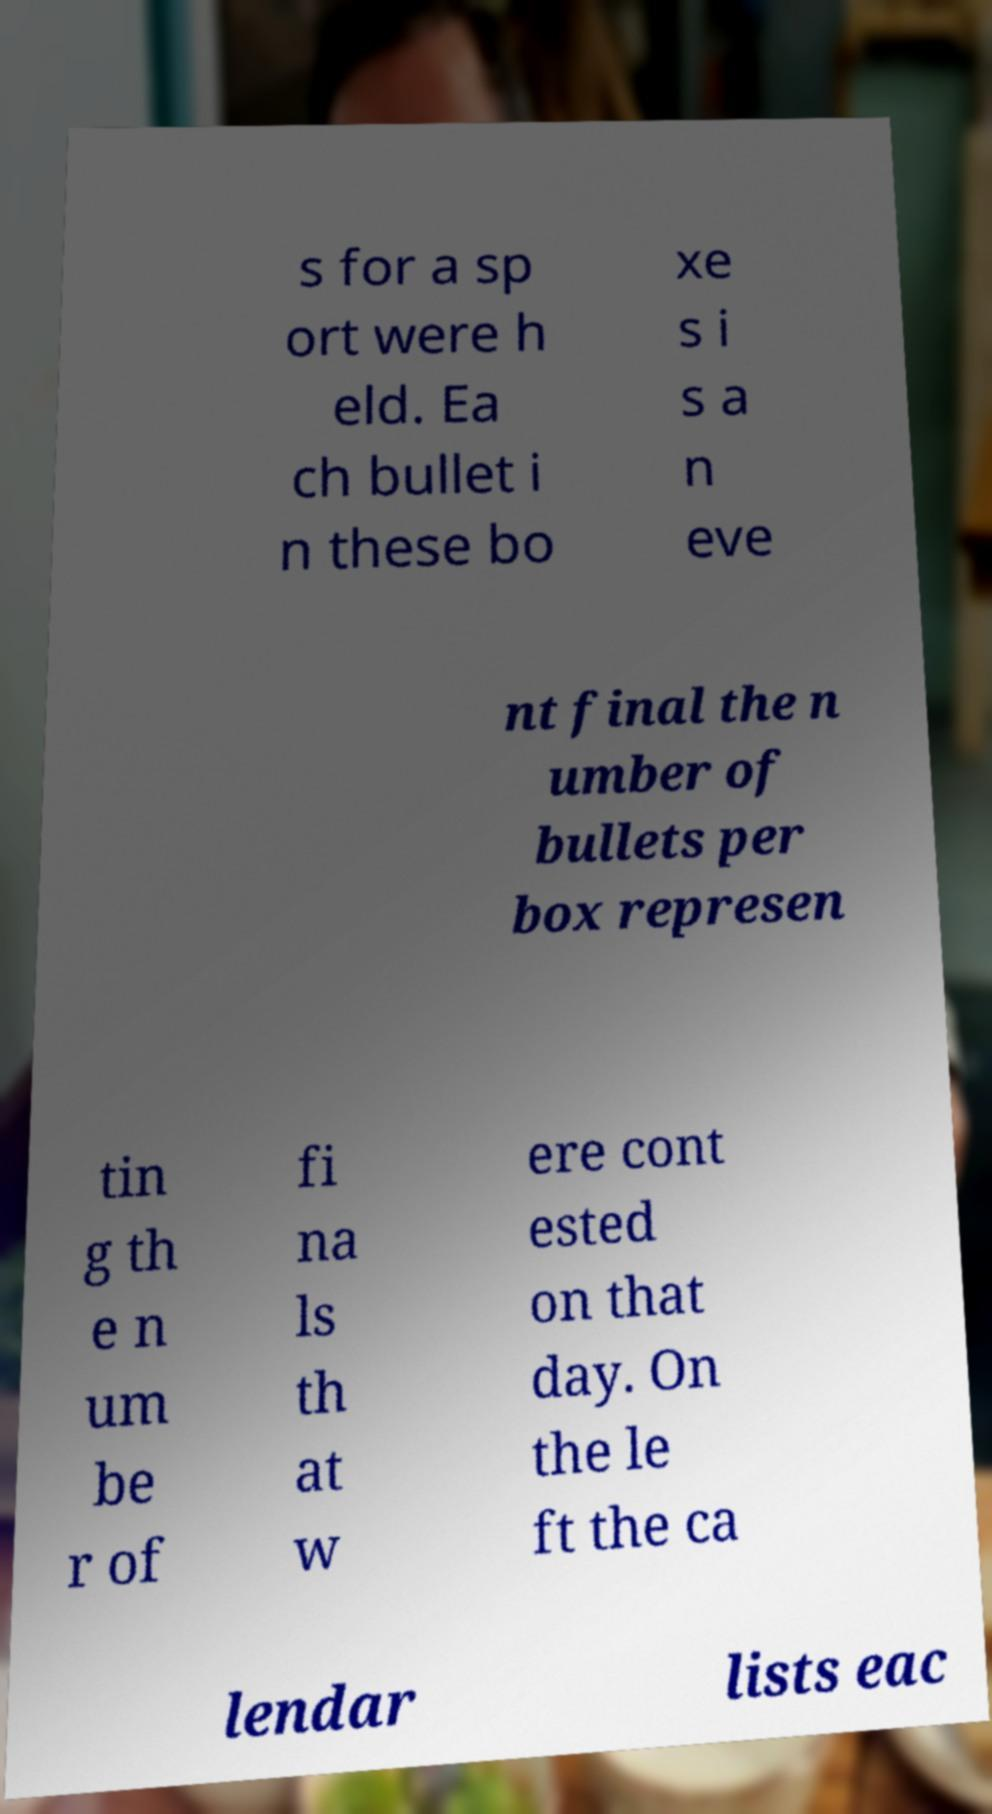Can you read and provide the text displayed in the image?This photo seems to have some interesting text. Can you extract and type it out for me? s for a sp ort were h eld. Ea ch bullet i n these bo xe s i s a n eve nt final the n umber of bullets per box represen tin g th e n um be r of fi na ls th at w ere cont ested on that day. On the le ft the ca lendar lists eac 